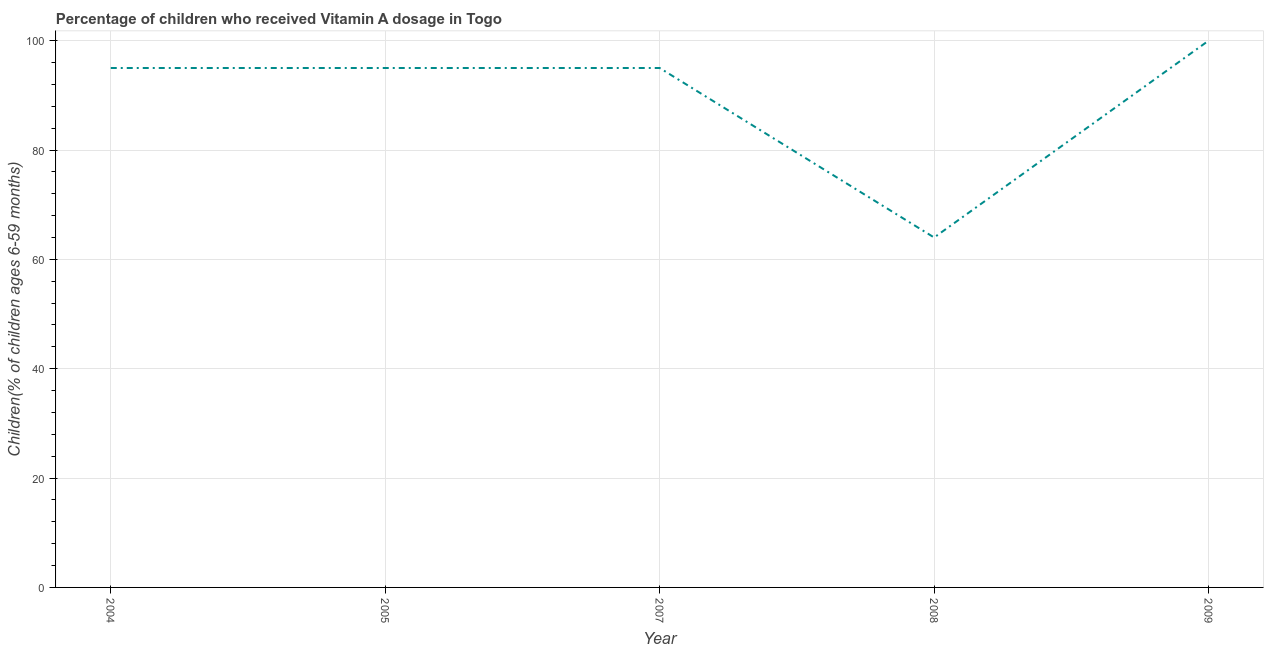What is the vitamin a supplementation coverage rate in 2004?
Your answer should be very brief. 95. Across all years, what is the maximum vitamin a supplementation coverage rate?
Make the answer very short. 100. Across all years, what is the minimum vitamin a supplementation coverage rate?
Provide a short and direct response. 64. In which year was the vitamin a supplementation coverage rate maximum?
Ensure brevity in your answer.  2009. What is the sum of the vitamin a supplementation coverage rate?
Offer a terse response. 449. What is the difference between the vitamin a supplementation coverage rate in 2008 and 2009?
Keep it short and to the point. -36. What is the average vitamin a supplementation coverage rate per year?
Keep it short and to the point. 89.8. What is the median vitamin a supplementation coverage rate?
Keep it short and to the point. 95. Do a majority of the years between 2009 and 2004 (inclusive) have vitamin a supplementation coverage rate greater than 60 %?
Your response must be concise. Yes. What is the ratio of the vitamin a supplementation coverage rate in 2008 to that in 2009?
Your answer should be compact. 0.64. Is the vitamin a supplementation coverage rate in 2005 less than that in 2007?
Make the answer very short. No. Is the difference between the vitamin a supplementation coverage rate in 2007 and 2009 greater than the difference between any two years?
Give a very brief answer. No. What is the difference between the highest and the lowest vitamin a supplementation coverage rate?
Make the answer very short. 36. Does the vitamin a supplementation coverage rate monotonically increase over the years?
Provide a short and direct response. No. Does the graph contain any zero values?
Offer a very short reply. No. What is the title of the graph?
Give a very brief answer. Percentage of children who received Vitamin A dosage in Togo. What is the label or title of the X-axis?
Keep it short and to the point. Year. What is the label or title of the Y-axis?
Your answer should be compact. Children(% of children ages 6-59 months). What is the Children(% of children ages 6-59 months) of 2007?
Offer a terse response. 95. What is the Children(% of children ages 6-59 months) in 2008?
Keep it short and to the point. 64. What is the Children(% of children ages 6-59 months) of 2009?
Give a very brief answer. 100. What is the difference between the Children(% of children ages 6-59 months) in 2004 and 2008?
Ensure brevity in your answer.  31. What is the difference between the Children(% of children ages 6-59 months) in 2005 and 2007?
Ensure brevity in your answer.  0. What is the difference between the Children(% of children ages 6-59 months) in 2005 and 2008?
Give a very brief answer. 31. What is the difference between the Children(% of children ages 6-59 months) in 2008 and 2009?
Give a very brief answer. -36. What is the ratio of the Children(% of children ages 6-59 months) in 2004 to that in 2007?
Your response must be concise. 1. What is the ratio of the Children(% of children ages 6-59 months) in 2004 to that in 2008?
Make the answer very short. 1.48. What is the ratio of the Children(% of children ages 6-59 months) in 2005 to that in 2008?
Make the answer very short. 1.48. What is the ratio of the Children(% of children ages 6-59 months) in 2007 to that in 2008?
Make the answer very short. 1.48. What is the ratio of the Children(% of children ages 6-59 months) in 2008 to that in 2009?
Offer a very short reply. 0.64. 